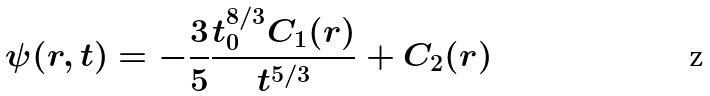Convert formula to latex. <formula><loc_0><loc_0><loc_500><loc_500>\psi ( r , t ) = - \frac { 3 } { 5 } \frac { t _ { 0 } ^ { 8 / 3 } C _ { 1 } ( r ) } { t ^ { 5 / 3 } } + C _ { 2 } ( r )</formula> 